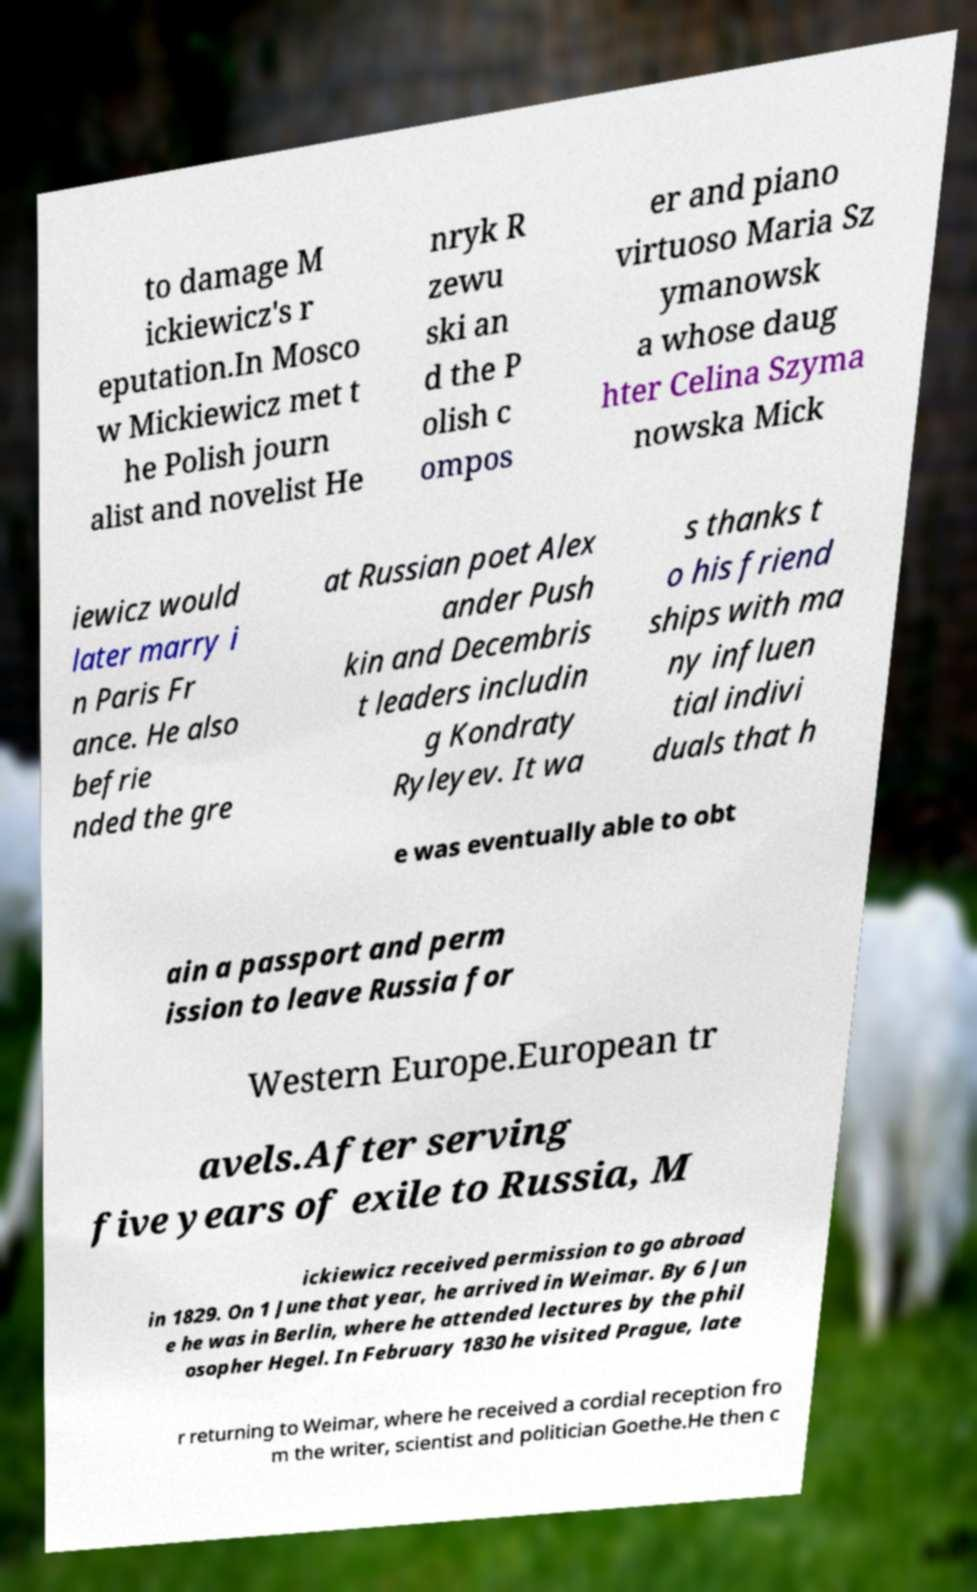There's text embedded in this image that I need extracted. Can you transcribe it verbatim? to damage M ickiewicz's r eputation.In Mosco w Mickiewicz met t he Polish journ alist and novelist He nryk R zewu ski an d the P olish c ompos er and piano virtuoso Maria Sz ymanowsk a whose daug hter Celina Szyma nowska Mick iewicz would later marry i n Paris Fr ance. He also befrie nded the gre at Russian poet Alex ander Push kin and Decembris t leaders includin g Kondraty Ryleyev. It wa s thanks t o his friend ships with ma ny influen tial indivi duals that h e was eventually able to obt ain a passport and perm ission to leave Russia for Western Europe.European tr avels.After serving five years of exile to Russia, M ickiewicz received permission to go abroad in 1829. On 1 June that year, he arrived in Weimar. By 6 Jun e he was in Berlin, where he attended lectures by the phil osopher Hegel. In February 1830 he visited Prague, late r returning to Weimar, where he received a cordial reception fro m the writer, scientist and politician Goethe.He then c 